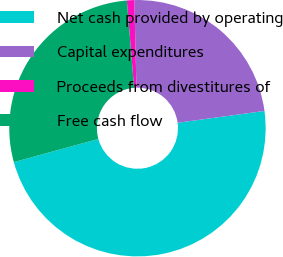Convert chart to OTSL. <chart><loc_0><loc_0><loc_500><loc_500><pie_chart><fcel>Net cash provided by operating<fcel>Capital expenditures<fcel>Proceeds from divestitures of<fcel>Free cash flow<nl><fcel>47.89%<fcel>23.24%<fcel>0.93%<fcel>27.94%<nl></chart> 